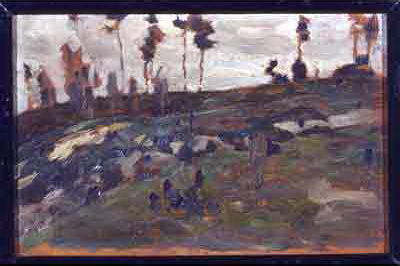What are the key elements in this picture? This impressionist landscape painting beautifully captures a serene, rocky hillside surrounded by thin, sporadic vegetation. The artist utilizes a subdued palette primarily consisting of deep browns, grays, and muted greens, with touches of blue that add depth and a hint of melancholy to the scene. The brushwork is deliberately loose and quick, typical of impressionism, to evoke the fleeting, transient moments of natural light and atmosphere. This approach not only highlights the textural variations of the terrain but also conveys a strong emotional undertone of solitude and contemplative peace, inviting the viewer to ponder the quiet beauty and ruggedness of nature. 